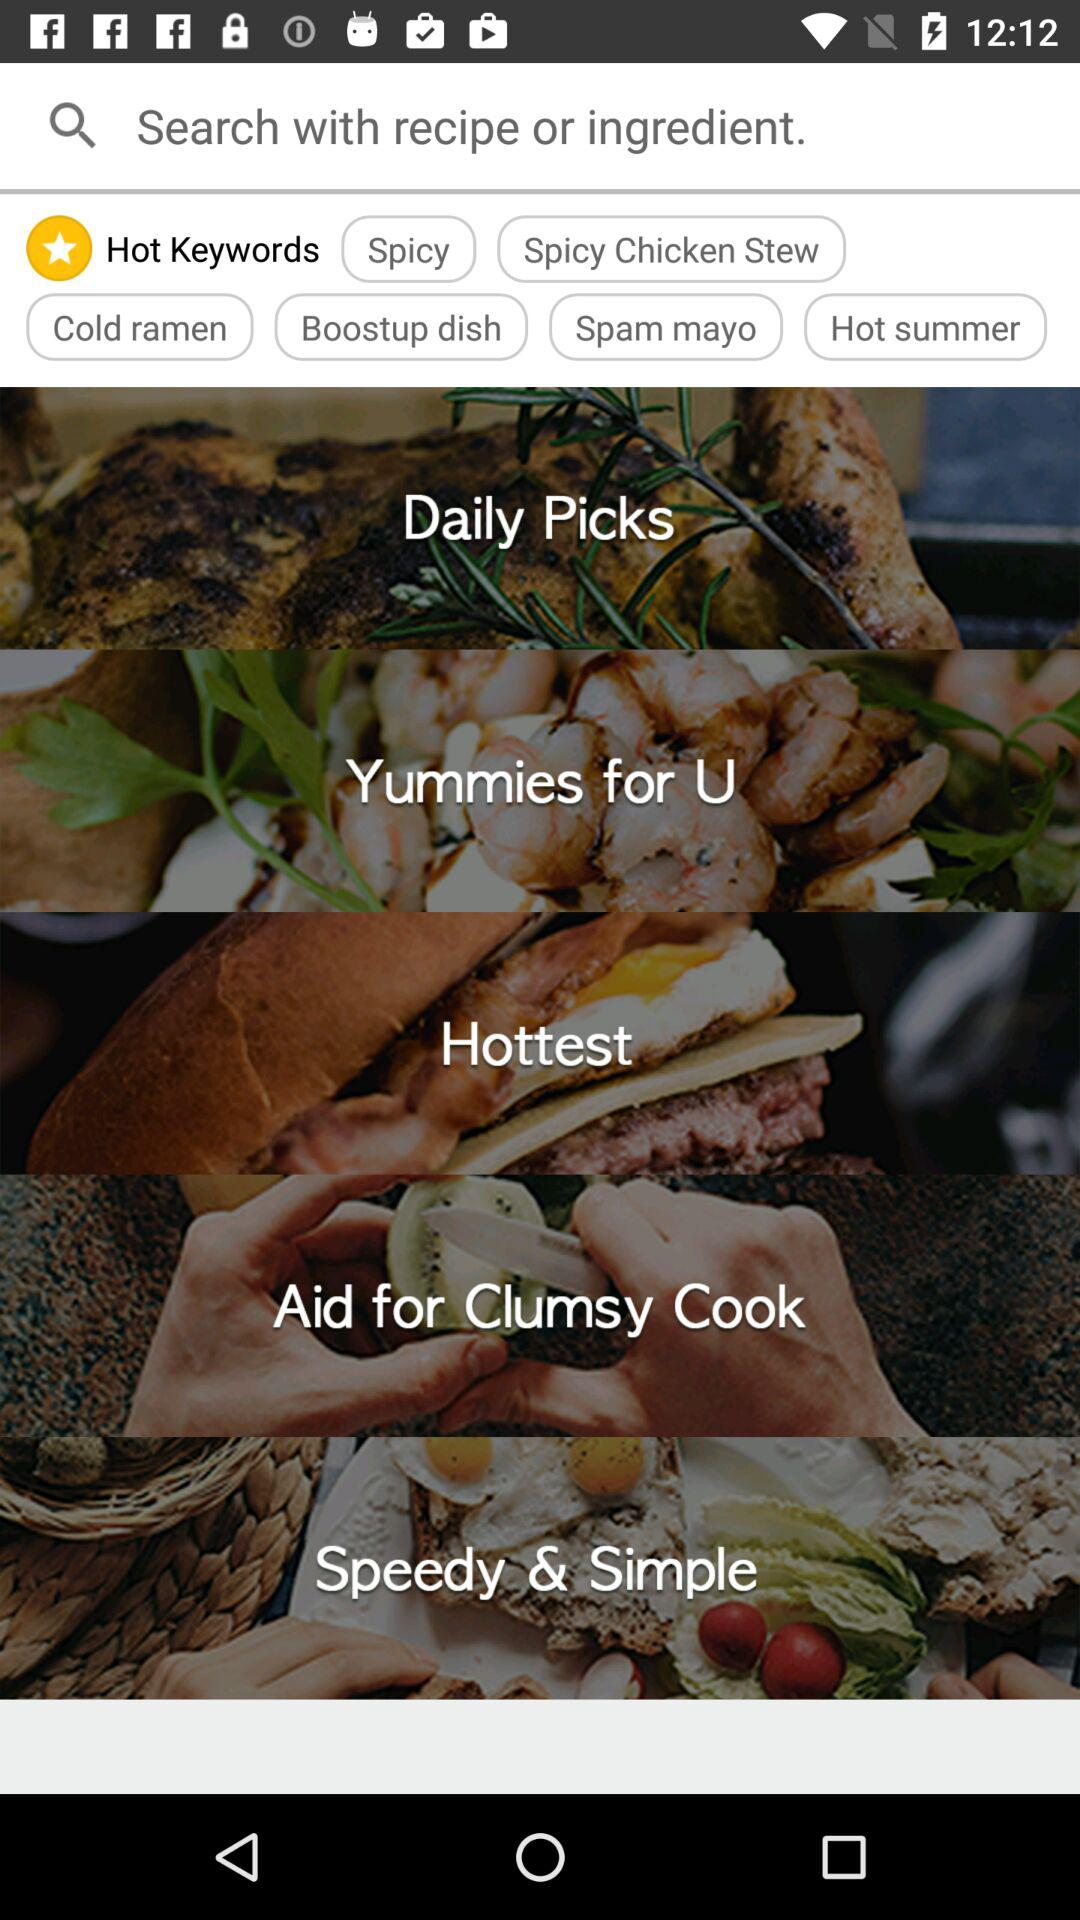What hot keywords are there? Hot keywords are "Spicy", "Spicy Chicken Stew", "Cold ramen", "Boostup dish", "Spam mayo" and "Hot summer". 